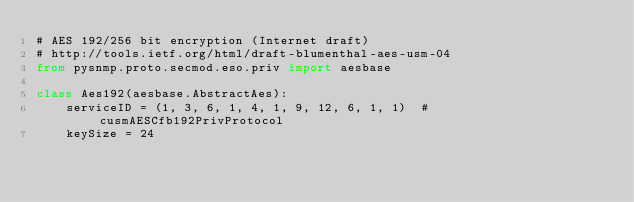<code> <loc_0><loc_0><loc_500><loc_500><_Python_># AES 192/256 bit encryption (Internet draft)
# http://tools.ietf.org/html/draft-blumenthal-aes-usm-04
from pysnmp.proto.secmod.eso.priv import aesbase

class Aes192(aesbase.AbstractAes):
    serviceID = (1, 3, 6, 1, 4, 1, 9, 12, 6, 1, 1)  # cusmAESCfb192PrivProtocol
    keySize = 24
</code> 